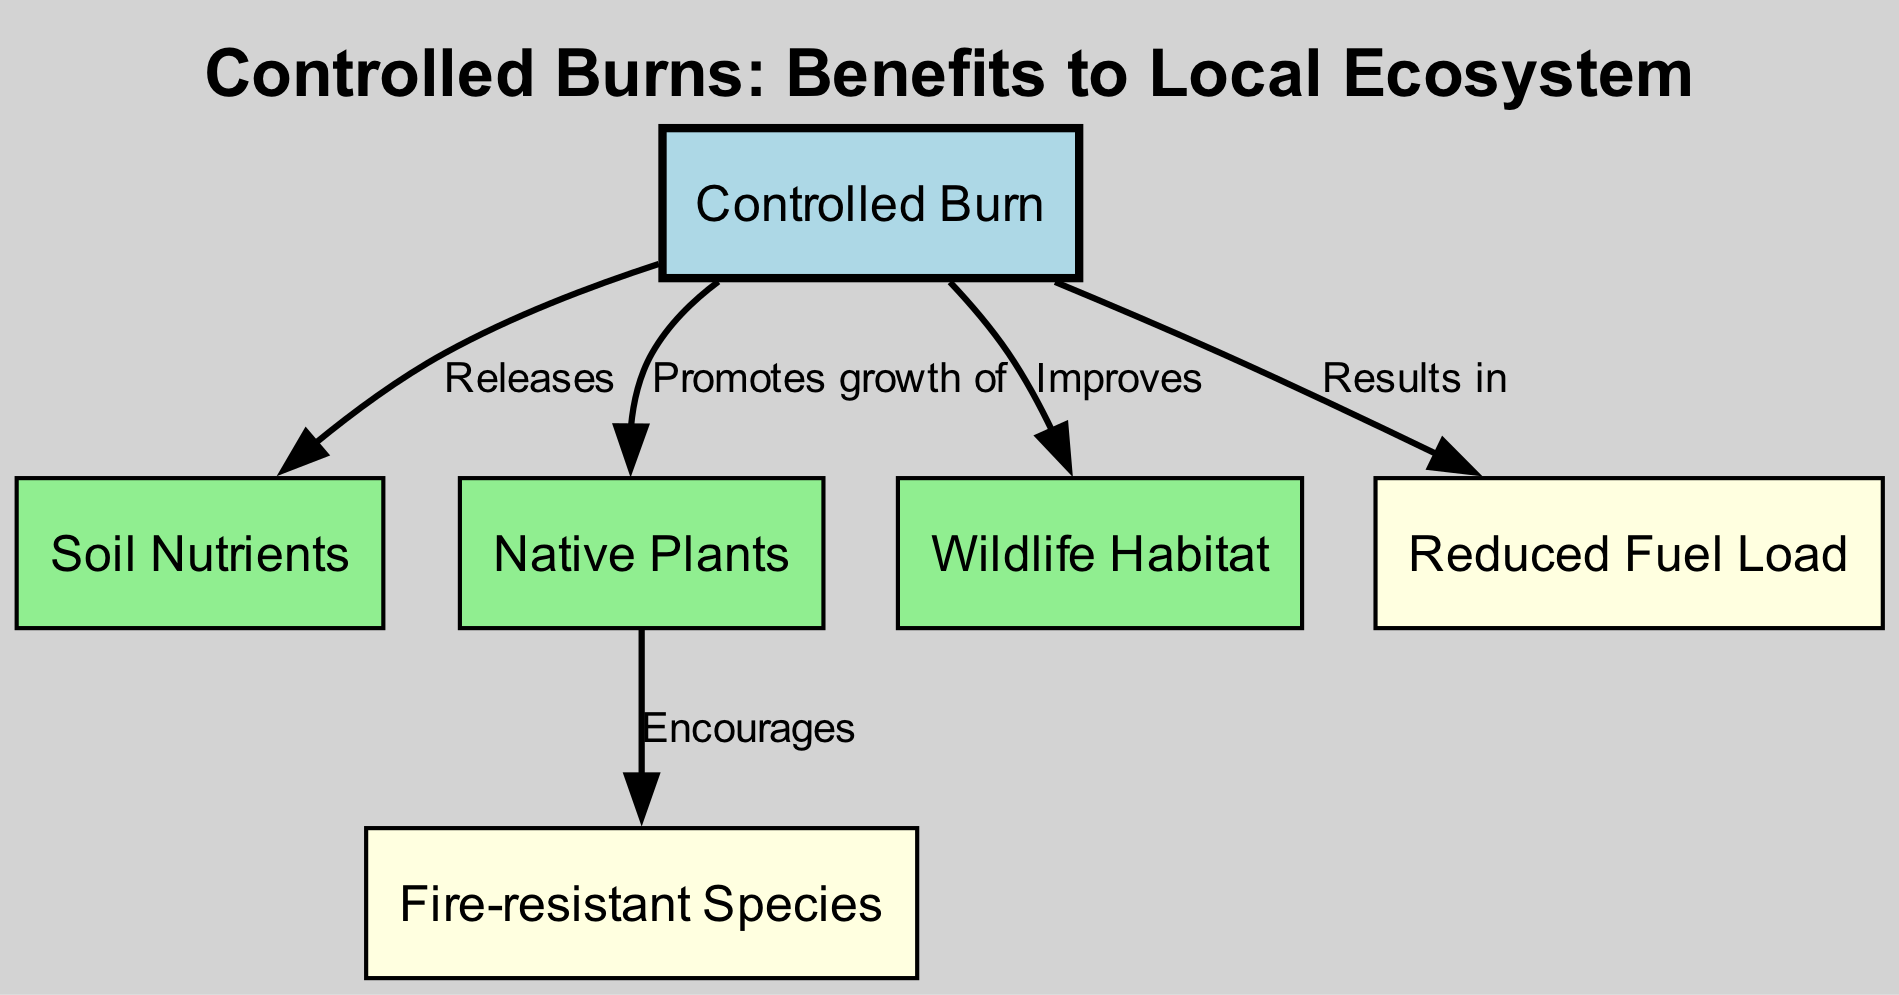What is the central node in the diagram? The central node is labeled "Controlled Burn," which is the starting point for the relationships depicted in the diagram.
Answer: Controlled Burn How many benefits are shown in the diagram? There are three benefits represented in the diagram, which are "Soil Nutrients," "Native Plants," and "Wildlife Habitat."
Answer: 3 What does a controlled burn result in? The diagram indicates that a controlled burn results in "Reduced Fuel Load," which helps manage fire hazards.
Answer: Reduced Fuel Load Which benefit promotes the growth of fire-resistant species? The benefit "Native Plants" is connected to the outcome labeled "Fire-resistant Species," indicating that encouraging native plants helps promote fire-resistant species.
Answer: Native Plants What relationship connects "Controlled Burn" to "Wildlife Habitat"? The relationship is described as "Improves," indicating that controlled burns improve the habitat for wildlife.
Answer: Improves How many edges are there in the diagram? The diagram contains five edges, which represent the relationships between the various nodes.
Answer: 5 What is the label for the edge connecting "Controlled Burn" to "Soil Nutrients"? The label for this edge is "Releases," indicating that controlled burns release nutrients into the soil.
Answer: Releases What type of diagram is this? This is a textbook diagram, specifically structured to illustrate the positive effects of controlled burns on local flora and fauna.
Answer: Textbook Diagram 